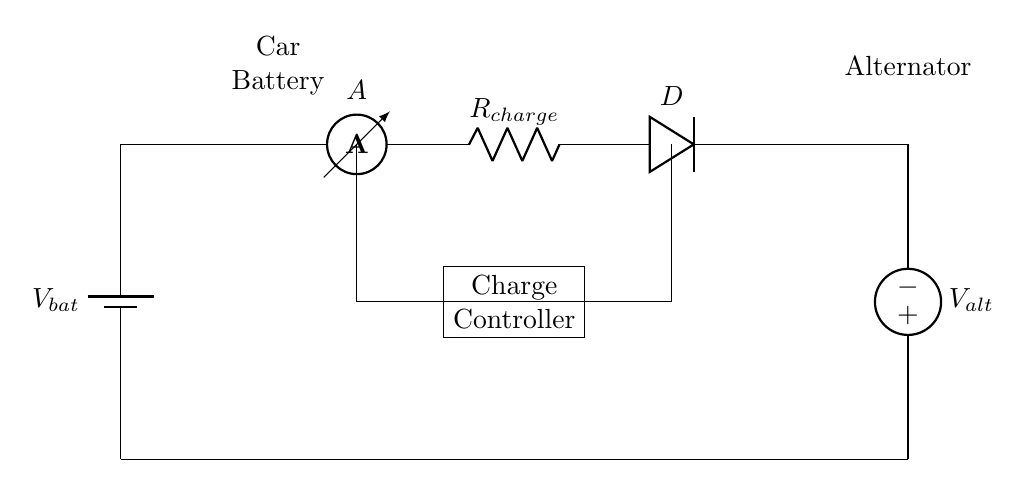what is the type of battery shown in the circuit? The circuit diagram displays a battery labeled as V_bat, indicating it is a car battery used for energy storage.
Answer: car battery what component measures the current in the circuit? The circuit has an ammeter labeled as A, which measures the flow of electric current passing through it.
Answer: ammeter what is the role of the diode in this circuit? The diode labeled as D allows current to flow in one direction while preventing reverse current, thus protecting the battery.
Answer: protect the battery how do you charge the car battery? The battery is charged by the voltage source V_alt, which is connected to the circuit, directing current through R_charge and the diode.
Answer: voltage source what does R_charge represent? R_charge is a resistor, which in this circuit controls the charging current flow to prevent overcharging of the battery.
Answer: resistor how many voltage sources are there in the circuit? The circuit contains two voltage sources: V_bat for the car battery and V_alt for the alternator providing charging voltage.
Answer: two what is the purpose of the charge controller in the circuit? The charge controller ensures optimal charging of the battery by regulating the current flow from the alternator and protecting against overcharging.
Answer: regulate charging 